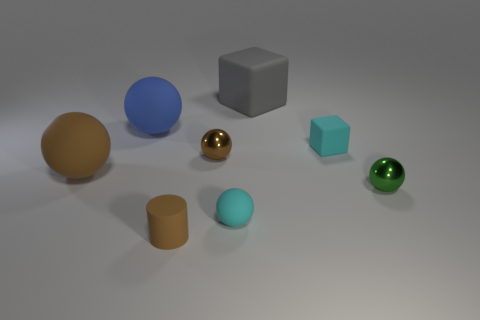What is the tiny brown object in front of the brown thing that is on the left side of the large blue matte thing made of?
Give a very brief answer. Rubber. How many large objects have the same color as the small cylinder?
Make the answer very short. 1. Are there any other rubber objects of the same shape as the large gray rubber object?
Provide a succinct answer. Yes. Is the number of tiny green things that are behind the large gray object the same as the number of brown things behind the big blue rubber object?
Ensure brevity in your answer.  Yes. There is a cyan rubber object that is to the left of the large block; is its shape the same as the big gray object?
Keep it short and to the point. No. Do the blue matte thing and the small green shiny object have the same shape?
Your response must be concise. Yes. What number of rubber objects are green things or big objects?
Keep it short and to the point. 3. There is a small ball that is the same color as the tiny cylinder; what material is it?
Ensure brevity in your answer.  Metal. Do the gray cube and the matte cylinder have the same size?
Provide a succinct answer. No. How many objects are either small cylinders or brown rubber cylinders to the left of the brown metallic thing?
Ensure brevity in your answer.  1. 